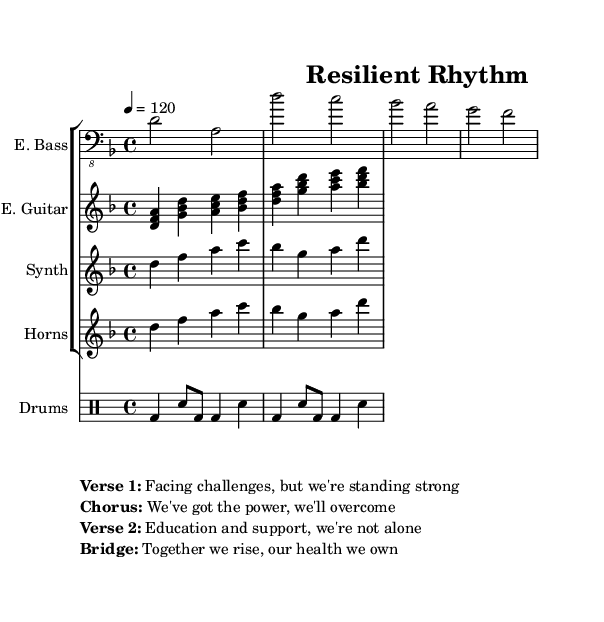What is the key signature of this music? The key signature is indicated at the beginning of the score, showing the 'D minor' key. D minor has one flat (B flat).
Answer: D minor What is the time signature of this music? The time signature is displayed prominently after the key signature, showing a '4/4' time signature, meaning there are four beats per measure.
Answer: 4/4 What is the tempo marking for this piece? The tempo marking, which indicates the speed of the piece, is specified at the beginning of the music as '4 = 120', meaning it should be played at a speed of 120 beats per minute.
Answer: 120 How many distinct vocal lines are present in the lyrics? The lyrics include four distinct lines: two verses, one chorus, and one bridge, as clearly marked in the score.
Answer: Four Which instruments are featured in this composition? The composition includes an electric bass, electric guitar, synth, and horns, as indicated by the instrument names in their respective staves at the beginning of the score.
Answer: Electric bass, electric guitar, synth, horns What is the underlying theme of this funk fusion piece? The lyrics indicate a theme centered on resilience and overcoming health challenges, as suggested by phrases like "Facing challenges" and "Together we rise."
Answer: Resilience Identify the emotional tone depicted in the chorus. The chorus communicates a sense of empowerment and optimism, with the phrase "We've got the power, we'll overcome" suggesting a positive emotional tone in line with the overarching theme of overcoming adversity.
Answer: Empowerment 